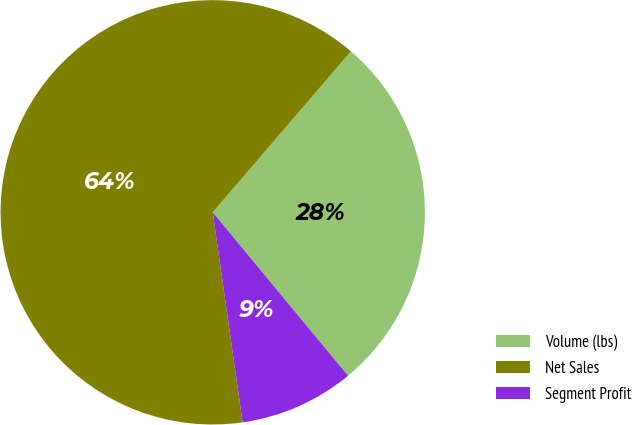Convert chart to OTSL. <chart><loc_0><loc_0><loc_500><loc_500><pie_chart><fcel>Volume (lbs)<fcel>Net Sales<fcel>Segment Profit<nl><fcel>27.7%<fcel>63.54%<fcel>8.76%<nl></chart> 